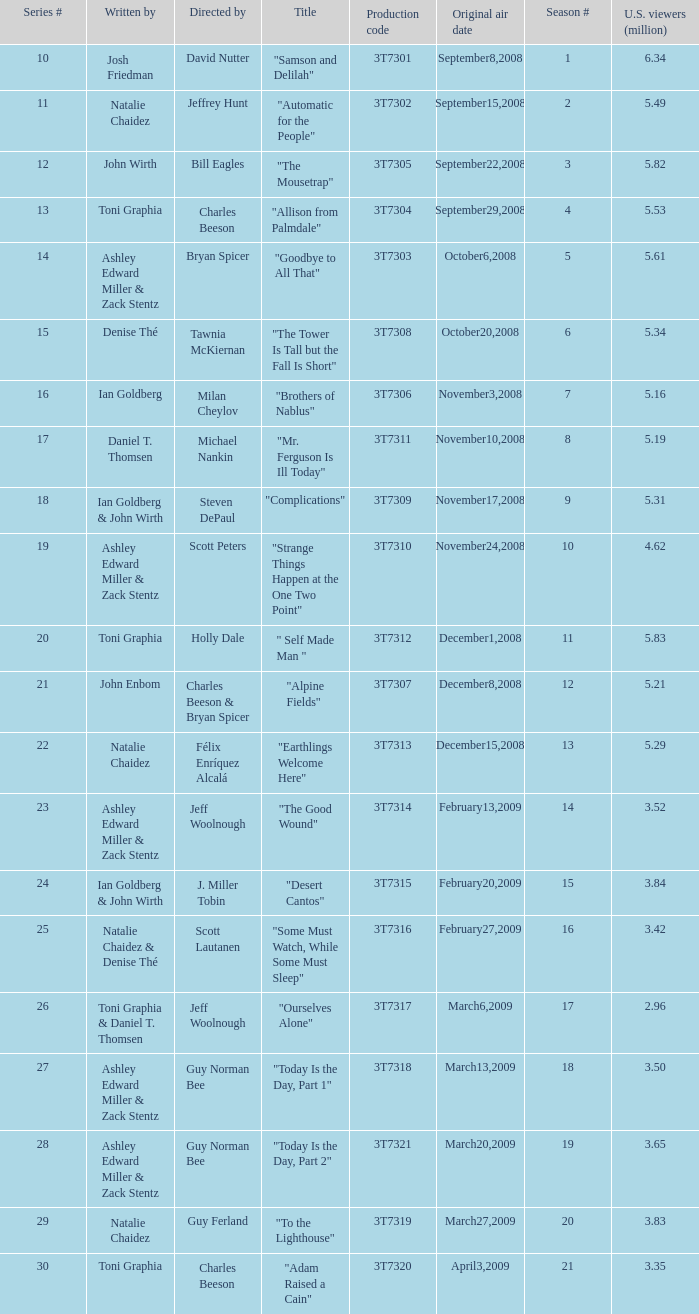Which episode number drew in 3.35 million viewers in the United States? 1.0. 